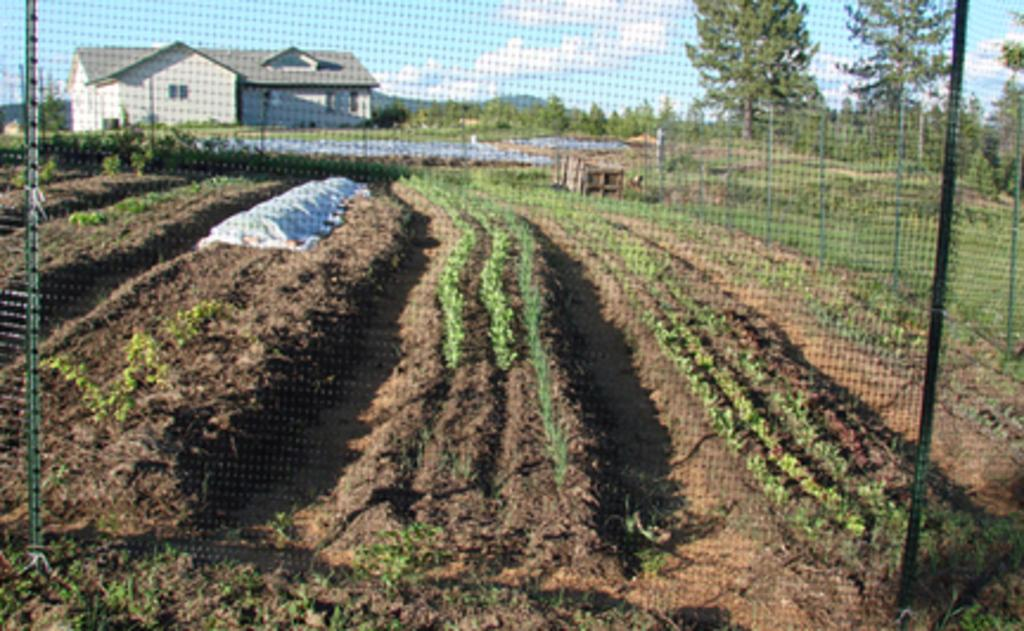What type of structures can be seen in the image? There are fences in the image. What type of vegetation is present in the image? There are garden plants and trees in the image. What type of landscape feature is visible in the image? There are mountains in the image. What type of building can be seen in the image? There is a building in the image. What is visible in the sky in the image? There are clouds in the sky in the image. What type of wax can be seen melting on the air in the image? There is no wax present in the image, and therefore no such activity can be observed. What season is depicted in the image? The provided facts do not mention a specific season, so it cannot be determined from the image. 